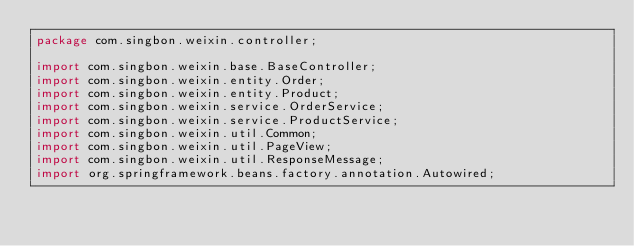<code> <loc_0><loc_0><loc_500><loc_500><_Java_>package com.singbon.weixin.controller;

import com.singbon.weixin.base.BaseController;
import com.singbon.weixin.entity.Order;
import com.singbon.weixin.entity.Product;
import com.singbon.weixin.service.OrderService;
import com.singbon.weixin.service.ProductService;
import com.singbon.weixin.util.Common;
import com.singbon.weixin.util.PageView;
import com.singbon.weixin.util.ResponseMessage;
import org.springframework.beans.factory.annotation.Autowired;</code> 